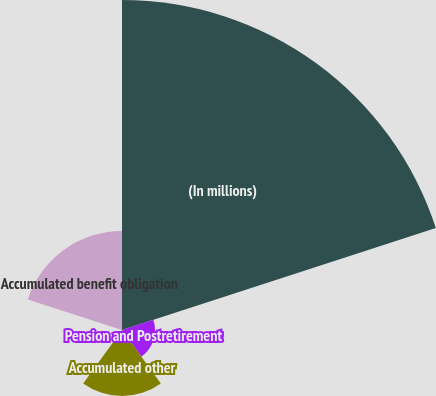Convert chart to OTSL. <chart><loc_0><loc_0><loc_500><loc_500><pie_chart><fcel>(In millions)<fcel>Pension and Postretirement<fcel>Accumulated other<fcel>Net amount recognized at end<fcel>Accumulated benefit obligation<nl><fcel>62.49%<fcel>6.25%<fcel>12.5%<fcel>0.0%<fcel>18.75%<nl></chart> 